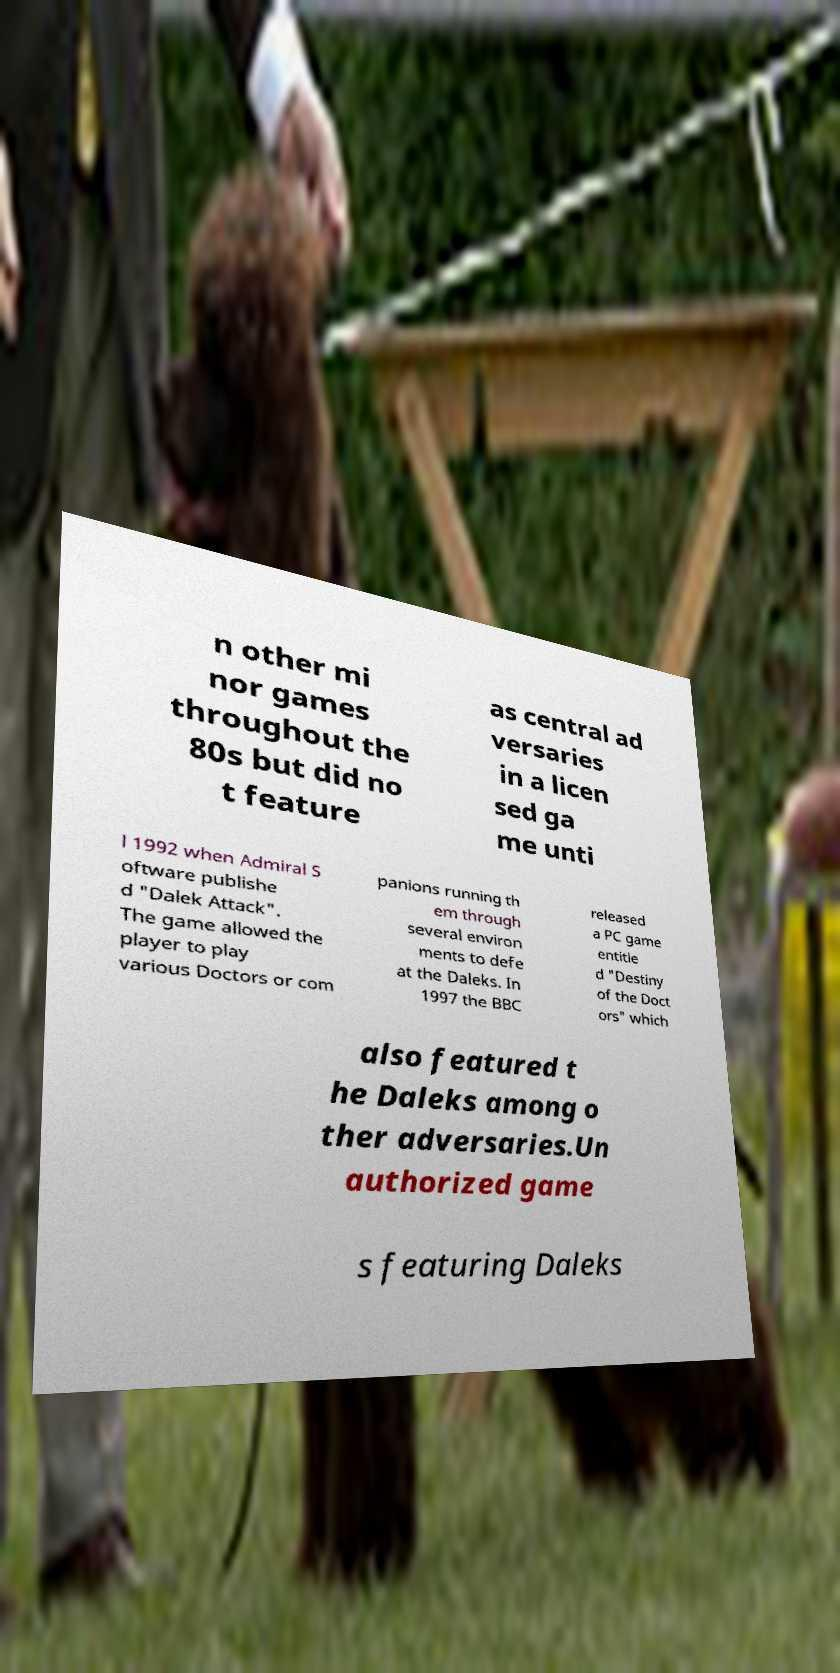Can you accurately transcribe the text from the provided image for me? n other mi nor games throughout the 80s but did no t feature as central ad versaries in a licen sed ga me unti l 1992 when Admiral S oftware publishe d "Dalek Attack". The game allowed the player to play various Doctors or com panions running th em through several environ ments to defe at the Daleks. In 1997 the BBC released a PC game entitle d "Destiny of the Doct ors" which also featured t he Daleks among o ther adversaries.Un authorized game s featuring Daleks 